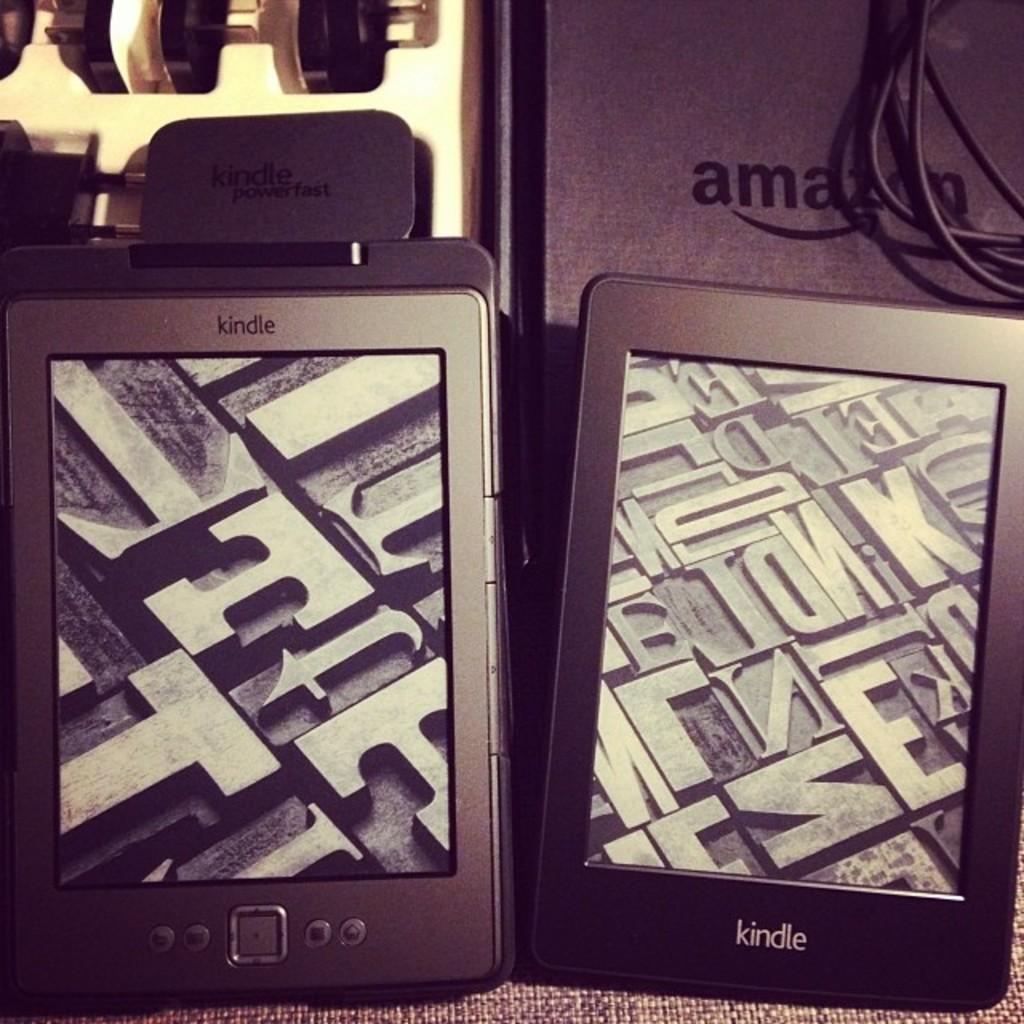<image>
Create a compact narrative representing the image presented. Two Amazon kindles sitting on the carpet with the charging port in a box nearby. 